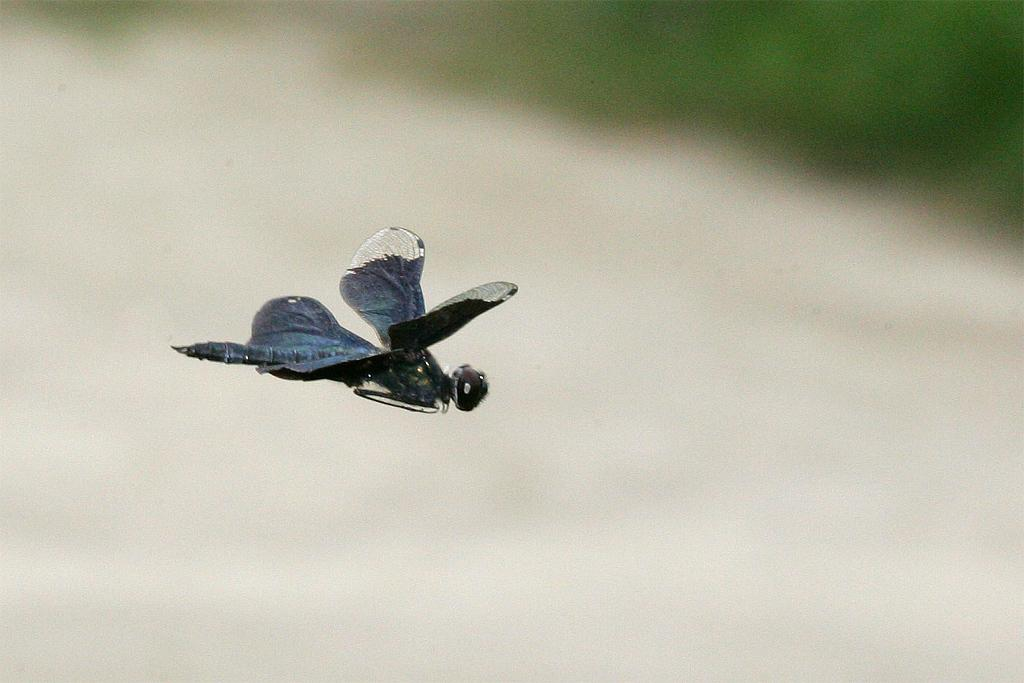What is the main subject of the image? There is a house fly in the center of the image. Can you describe the background of the image? The background of the image is blurred. What type of gun is being used by the insect in the image? There is no gun or insect present in the image; it features a house fly. What songs can be heard playing in the background of the image? There is no audio or music present in the image, so it cannot be determined what songs might be heard. 